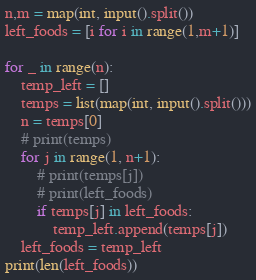<code> <loc_0><loc_0><loc_500><loc_500><_Python_>n,m = map(int, input().split())
left_foods = [i for i in range(1,m+1)]

for _ in range(n):
    temp_left = []
    temps = list(map(int, input().split()))
    n = temps[0]
    # print(temps)
    for j in range(1, n+1):
        # print(temps[j])
        # print(left_foods)
        if temps[j] in left_foods:
            temp_left.append(temps[j])
    left_foods = temp_left
print(len(left_foods))</code> 